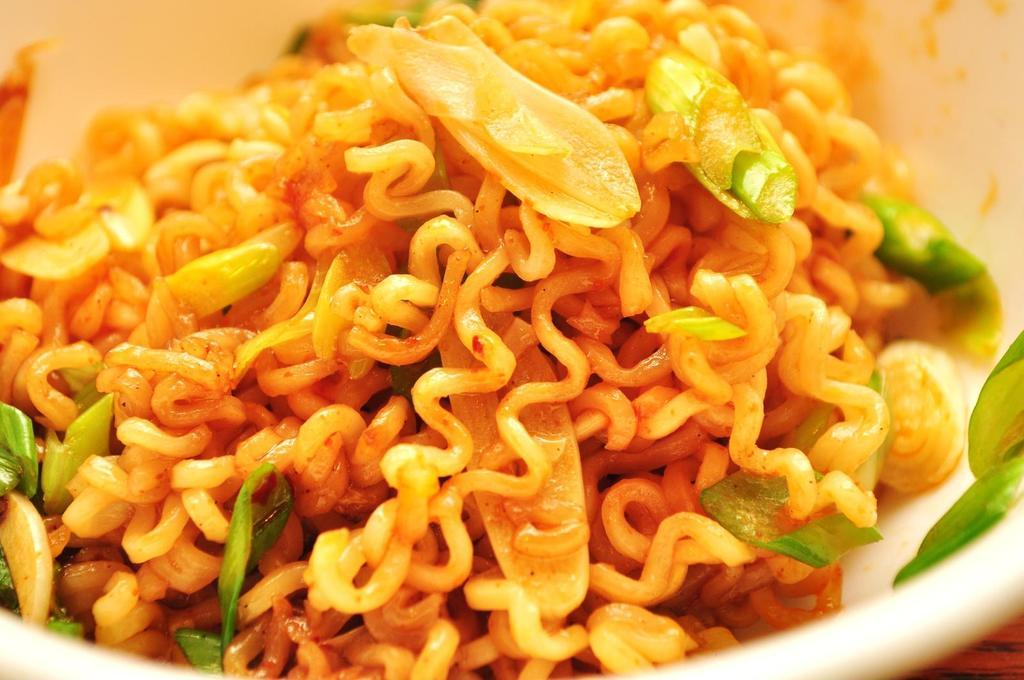What type of food is visible in the image? There are cooked noodles in the image. What color is the bowl containing the noodles? The bowl is white in color. What type of engine is powering the noodles in the image? There is no engine present in the image, as it features cooked noodles in a bowl. 